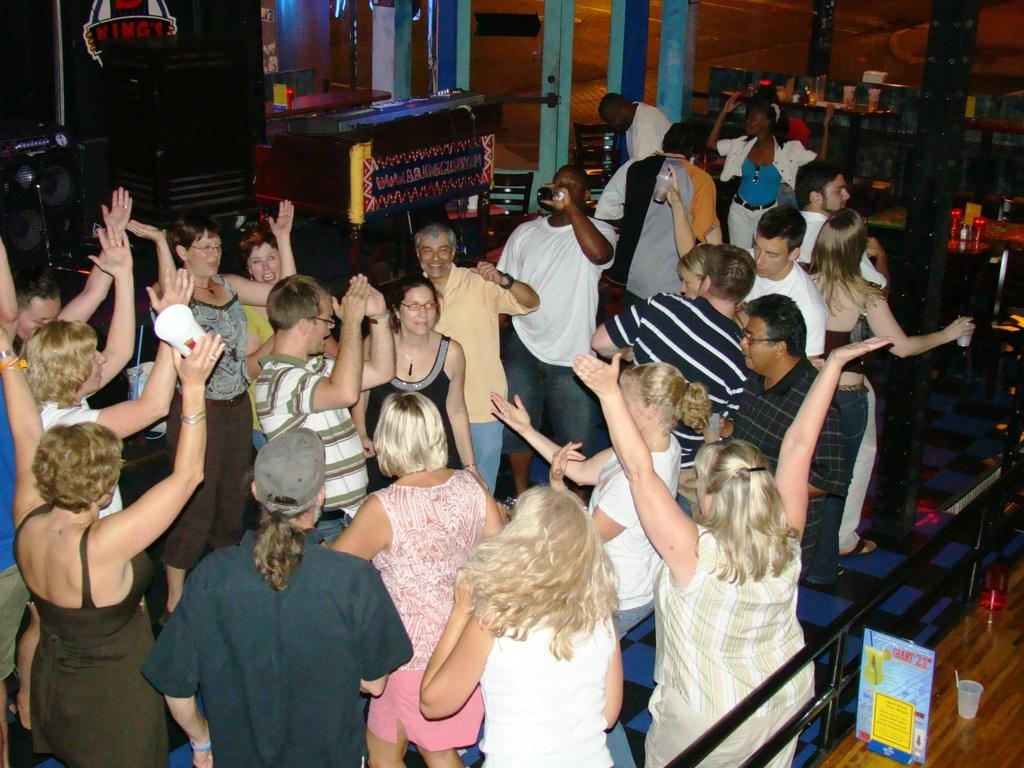How many people can be seen in the image? There are people in the image, but the exact number is not specified. What can be seen near the people in the image? There is railing visible in the image. What is the board in the image used for? The purpose of the board in the image is not specified. What material is the glass in the image made of? The material of the glass in the image is not specified. What objects are on the table in the image? There are objects on a table in the image, but their specific nature is not mentioned. What type of device is on the table in the background of the image? The type of device on the table in the background of the image is not specified. What can be heard from the speakers in the background of the image? The sound coming from the speakers in the background of the image is not specified. What is the purpose of the door in the background of the image? The purpose of the door in the background of the image is not specified. Can you see the vein of the quince tree in the image? There is no quince tree or vein visible in the image. What type of beam is holding up the ceiling in the image? There is no mention of a ceiling or beam in the image. 